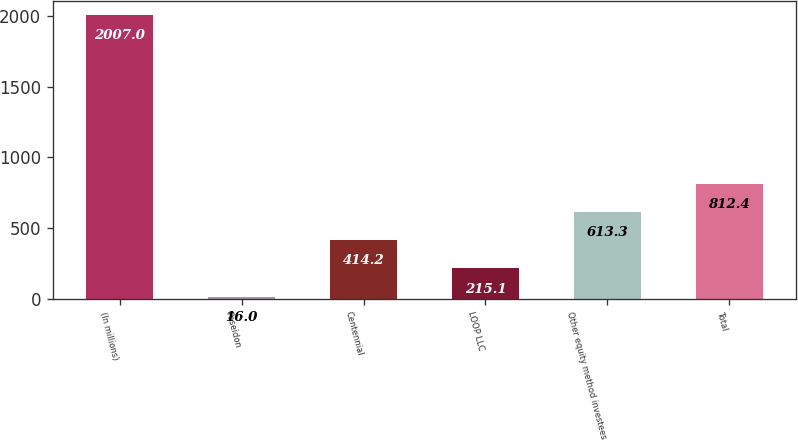Convert chart. <chart><loc_0><loc_0><loc_500><loc_500><bar_chart><fcel>(In millions)<fcel>Poseidon<fcel>Centennial<fcel>LOOP LLC<fcel>Other equity method investees<fcel>Total<nl><fcel>2007<fcel>16<fcel>414.2<fcel>215.1<fcel>613.3<fcel>812.4<nl></chart> 